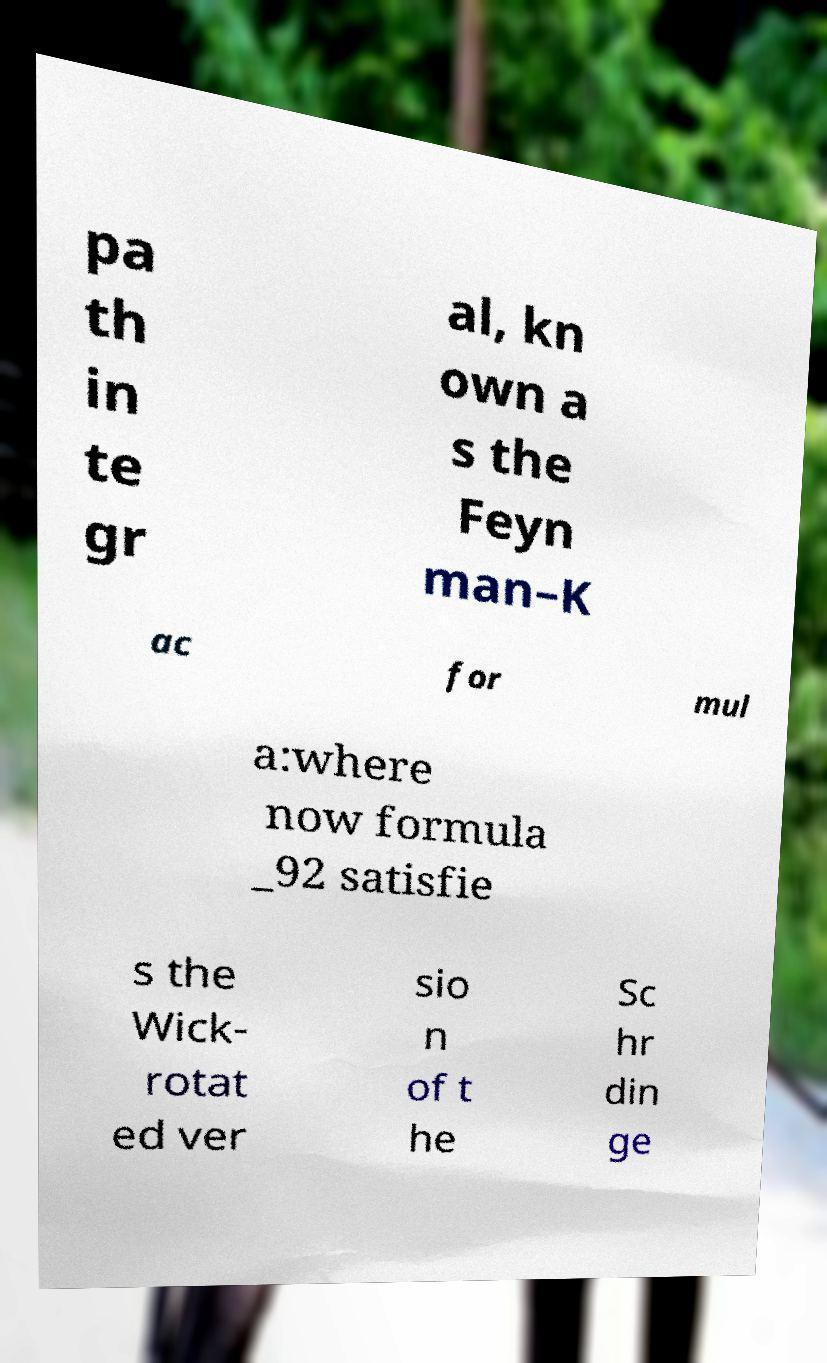Could you extract and type out the text from this image? pa th in te gr al, kn own a s the Feyn man–K ac for mul a:where now formula _92 satisfie s the Wick- rotat ed ver sio n of t he Sc hr din ge 